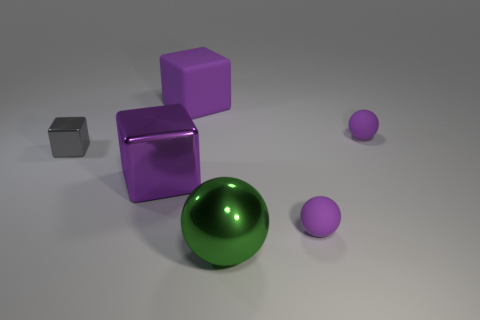What number of large purple rubber blocks are behind the large green shiny ball?
Your answer should be very brief. 1. Is the number of purple matte spheres to the left of the large green shiny sphere less than the number of things in front of the tiny metallic block?
Provide a short and direct response. Yes. What shape is the large purple object in front of the purple rubber thing behind the small matte sphere behind the big purple metallic cube?
Ensure brevity in your answer.  Cube. The object that is both in front of the large purple shiny object and behind the green thing has what shape?
Give a very brief answer. Sphere. Are there any large purple objects that have the same material as the small gray cube?
Your answer should be very brief. Yes. There is a shiny block that is the same color as the matte cube; what size is it?
Your response must be concise. Large. What color is the tiny thing that is on the left side of the large sphere?
Your answer should be compact. Gray. Is the shape of the small metal object the same as the big object in front of the purple shiny block?
Give a very brief answer. No. Are there any things that have the same color as the large metal block?
Your answer should be very brief. Yes. What size is the gray object that is the same material as the green thing?
Your answer should be compact. Small. 